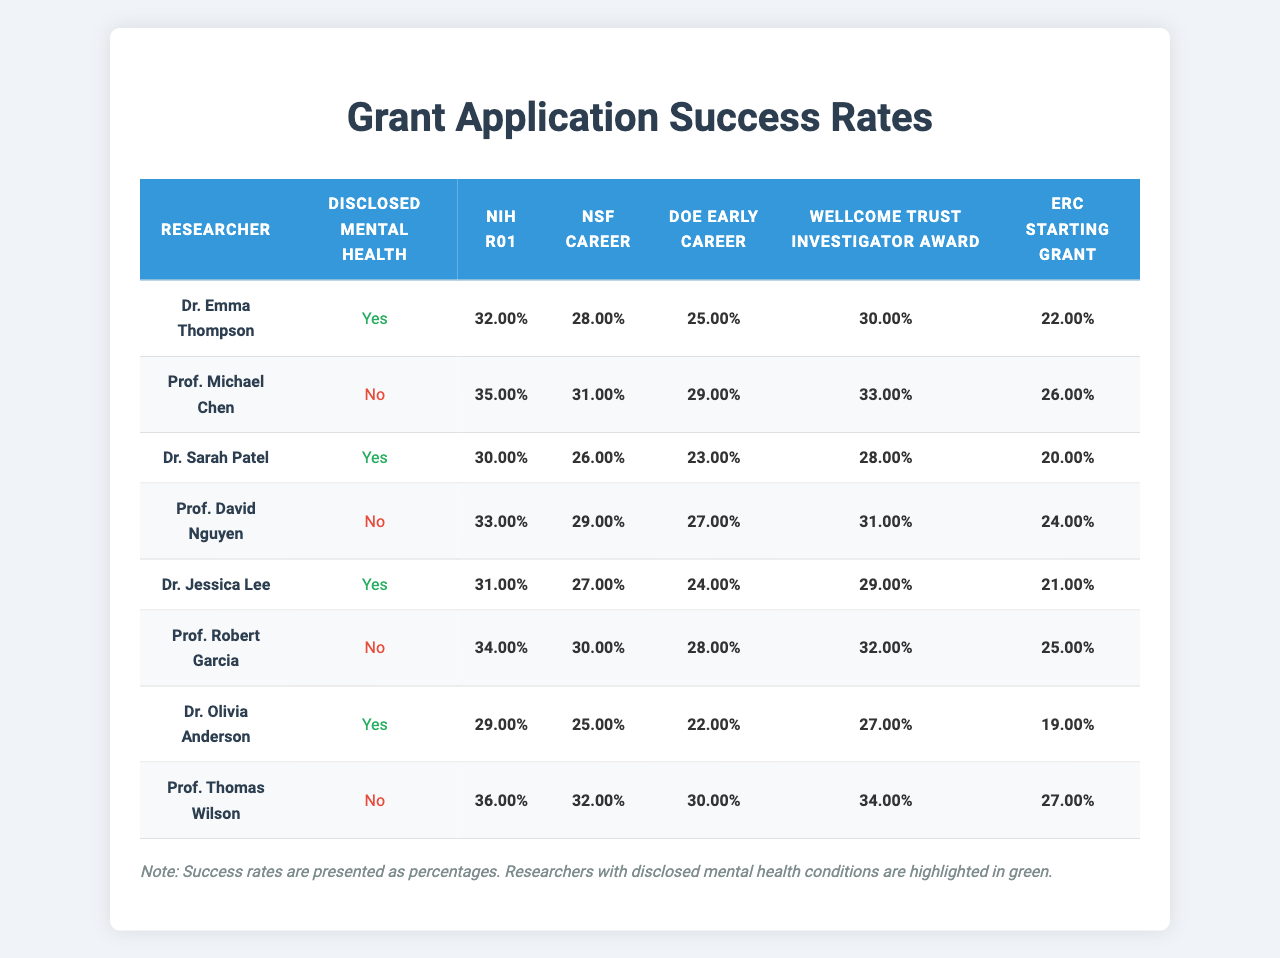What is the success rate of Dr. Emma Thompson's NIH R01 grant application? The table presents the success rates for various grant types. For Dr. Emma Thompson, the success rate for the NIH R01 grant application is 32%.
Answer: 32% What percentage of researchers have disclosed mental health conditions? Out of 8 researchers, 4 have disclosed mental health conditions. To find the percentage, divide 4 by 8 and multiply by 100, which gives 50%.
Answer: 50% Who has the highest success rate for the ERC Starting Grant? By reviewing the success rates of all researchers for the ERC Starting Grant, Prof. Thomas Wilson has the highest success rate at 27%.
Answer: Prof. Thomas Wilson What is the average success rate for researchers with disclosed mental health conditions across all grant types? The success rates for researchers with disclosed mental health conditions are 0.32, 0.30, 0.31, and 0.29 for the NIH R01, DOE Early Career, ERC Starting Grant, and Wellcome Trust respectively, which sums to 1.22. There are 4 researchers, so the average is 1.22/4 = 0.305 or 30.5%.
Answer: 30.5% Does Dr. Jessica Lee have a higher success rate with the NSF CAREER grant than Dr. Sarah Patel? Dr. Jessica Lee's success rate for the NSF CAREER grant is 27%, while Dr. Sarah Patel's is 26%. Comparing these values shows that Dr. Jessica Lee has a higher success rate.
Answer: Yes What is the difference in success rates for the Wellcome Trust Investigator Award between the highest and lowest scoring researchers? The highest success rate for the Wellcome Trust Investigator Award is 34% (Prof. Thomas Wilson) and the lowest is 20% (Dr. Sarah Patel). The difference is 34% - 20% = 14%.
Answer: 14% What is the success rate of Prof. Robert Garcia for the DOE Early Career grant, and does he have a disclosed mental health condition? The success rate for Prof. Robert Garcia for the DOE Early Career grant is 28%, and he does not have a disclosed mental health condition.
Answer: 28%, No Are there more researchers with disclosed mental health conditions or without? There are 4 researchers with disclosed mental health conditions and 4 without. This shows an equal number of both groups.
Answer: Equal Which grant type has the lowest overall success rate for researchers with disclosed mental health conditions? Reviewing the success rates, the lowest rate for the group with disclosed mental health conditions is 22% for the ERC Starting Grant.
Answer: ERC Starting Grant What is the average success rate of researchers without disclosed mental health conditions for the NIH R01 and NSF CAREER grants combined? For the NIH R01 grant, the rate is 0.35 and for the NSF CAREER grant it is 0.31. Summing these gives 0.66, and dividing by 2 (for 2 grants) gives an average of 0.33 or 33%.
Answer: 33% 